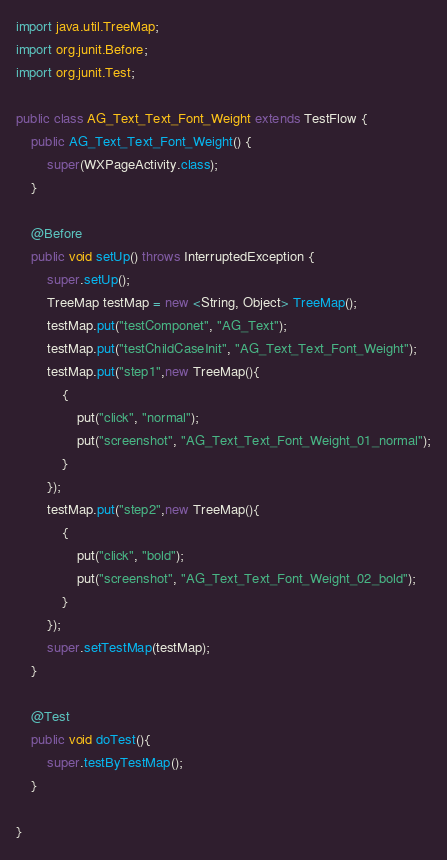<code> <loc_0><loc_0><loc_500><loc_500><_Java_>import java.util.TreeMap;
import org.junit.Before;
import org.junit.Test;

public class AG_Text_Text_Font_Weight extends TestFlow {
	public AG_Text_Text_Font_Weight() {
		super(WXPageActivity.class);
	}

	@Before
	public void setUp() throws InterruptedException {
		super.setUp();
		TreeMap testMap = new <String, Object> TreeMap();
		testMap.put("testComponet", "AG_Text");
		testMap.put("testChildCaseInit", "AG_Text_Text_Font_Weight");
		testMap.put("step1",new TreeMap(){
			{
				put("click", "normal");
				put("screenshot", "AG_Text_Text_Font_Weight_01_normal");
			}
		});
		testMap.put("step2",new TreeMap(){
			{
				put("click", "bold");
				put("screenshot", "AG_Text_Text_Font_Weight_02_bold");
			}
		});
		super.setTestMap(testMap);
	}

	@Test
	public void doTest(){
		super.testByTestMap();
	}

}
</code> 